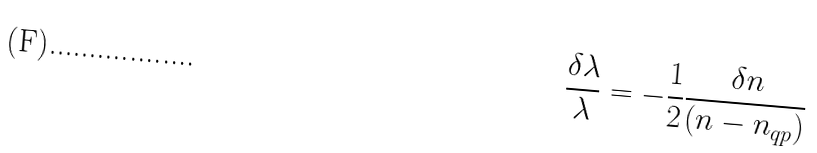Convert formula to latex. <formula><loc_0><loc_0><loc_500><loc_500>\frac { \delta \lambda } { \lambda } = - \frac { 1 } { 2 } \frac { \delta n } { ( n - n _ { q p } ) }</formula> 